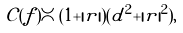Convert formula to latex. <formula><loc_0><loc_0><loc_500><loc_500>\mathcal { C } ( f ) \asymp ( 1 + | r | ) ( d ^ { 2 } + | r | ^ { 2 } ) ,</formula> 